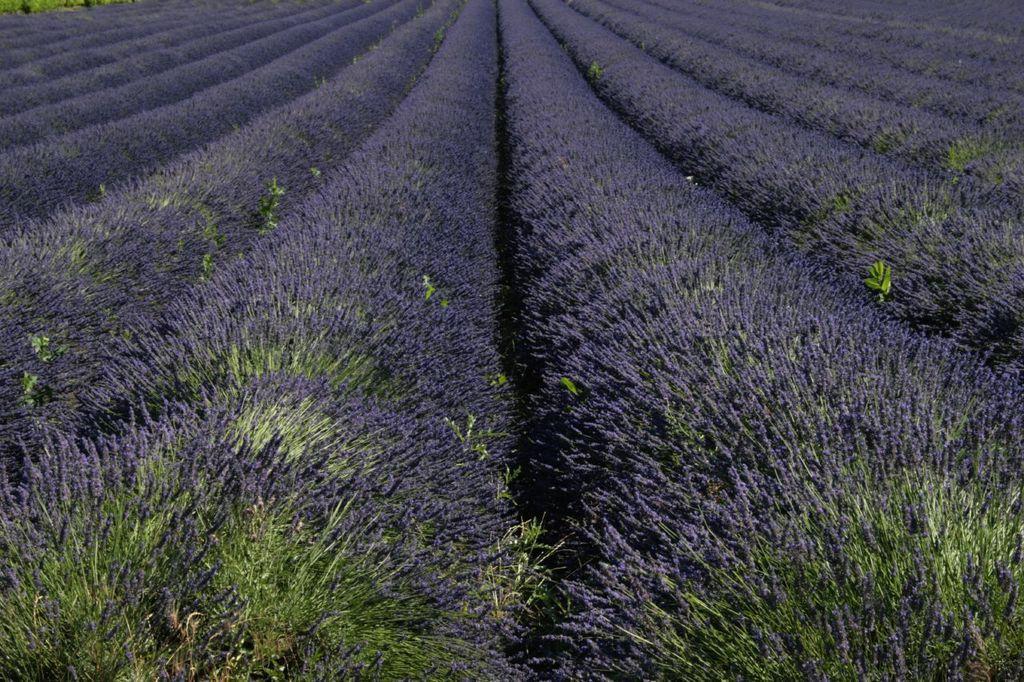Could you give a brief overview of what you see in this image? In the foreground of this image, there are lavender colored plants. 